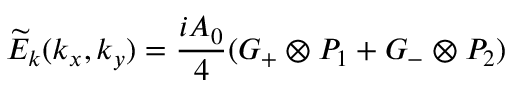Convert formula to latex. <formula><loc_0><loc_0><loc_500><loc_500>{ \widetilde { E } _ { k } } ( { k _ { x } } , { k _ { y } } ) = \frac { i A _ { 0 } } { 4 } ( { G _ { + } } \otimes { P _ { 1 } } + { G _ { - } } \otimes { P _ { 2 } } )</formula> 